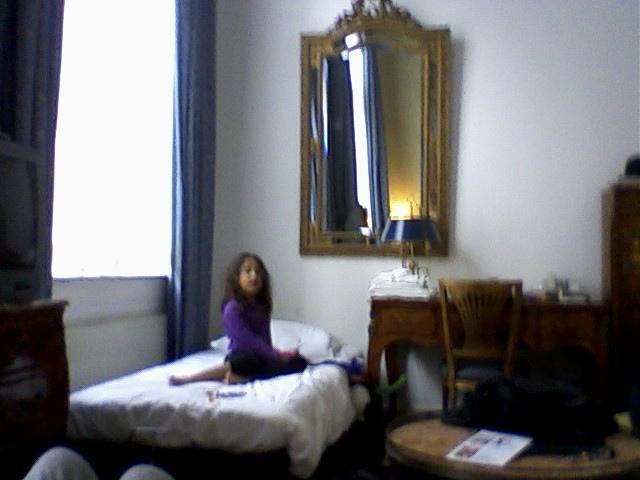How many pillows are on the bed?
Give a very brief answer. 1. How many people are in the picture?
Give a very brief answer. 2. 